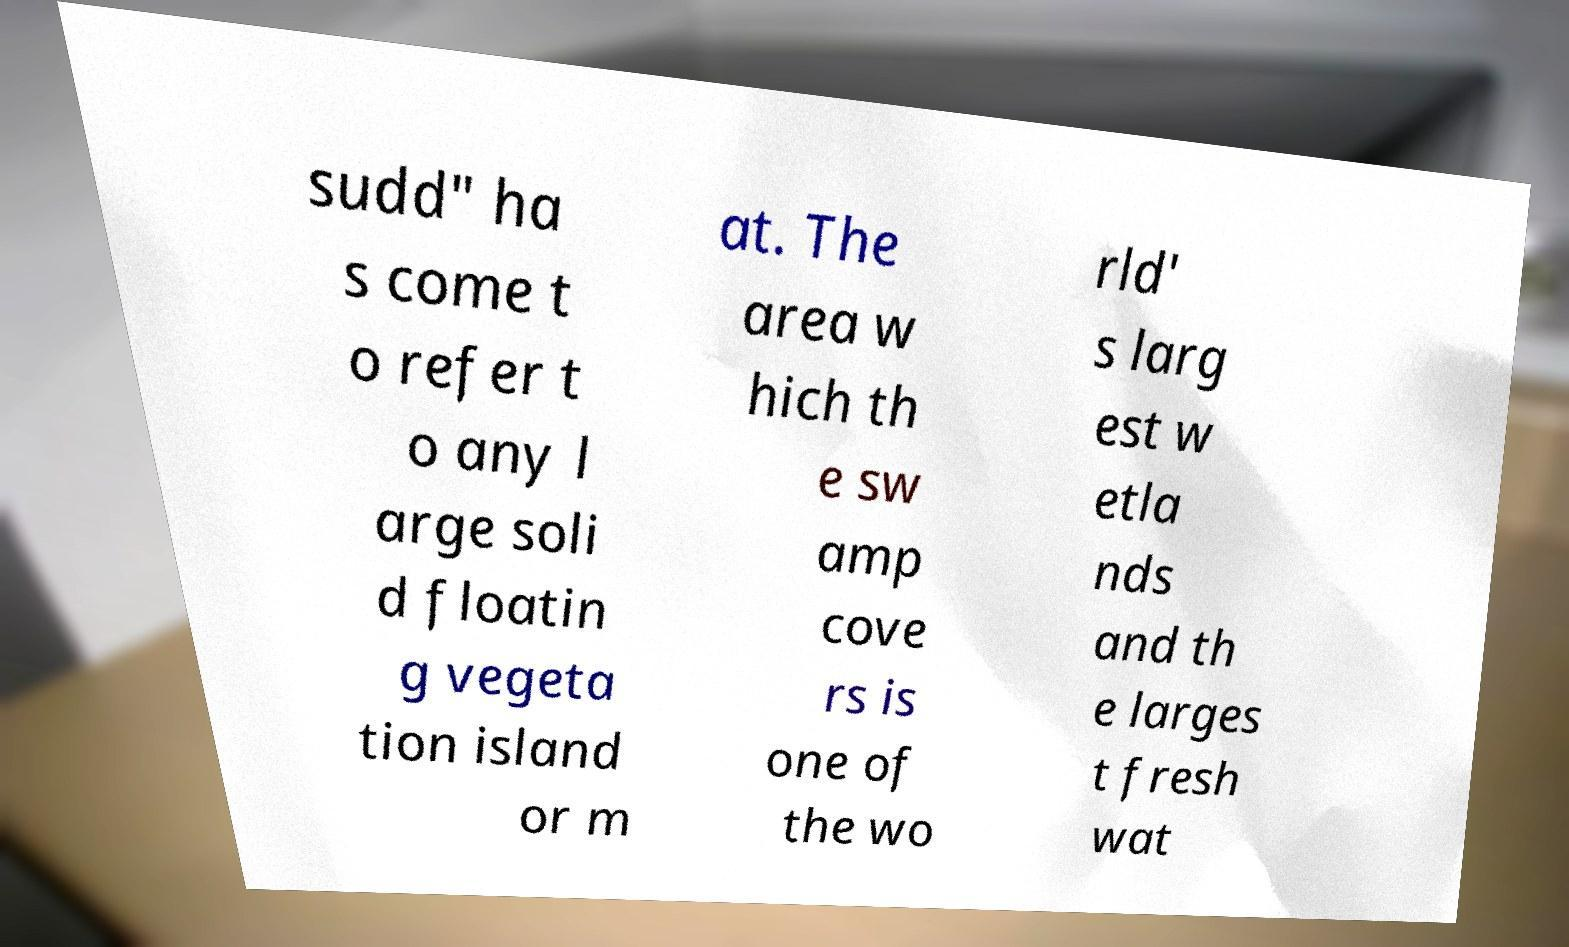For documentation purposes, I need the text within this image transcribed. Could you provide that? sudd" ha s come t o refer t o any l arge soli d floatin g vegeta tion island or m at. The area w hich th e sw amp cove rs is one of the wo rld' s larg est w etla nds and th e larges t fresh wat 